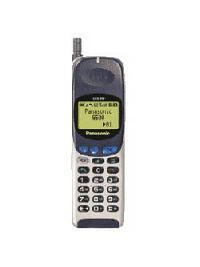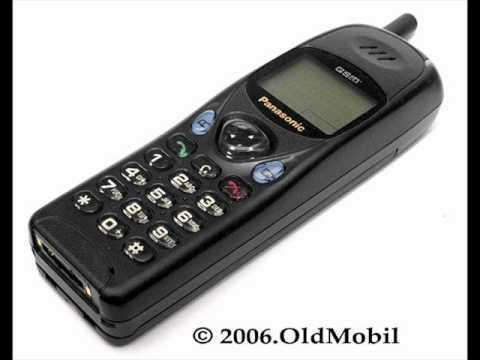The first image is the image on the left, the second image is the image on the right. Analyze the images presented: Is the assertion "In at least one image the is a single phone with a clear but blue button  in the middle of the phone representing 4 arrow keys." valid? Answer yes or no. No. The first image is the image on the left, the second image is the image on the right. Evaluate the accuracy of this statement regarding the images: "Each image contains one narrow rectangular phone displayed vertically, with an antenna projecting from the top left of the phone.". Is it true? Answer yes or no. No. 